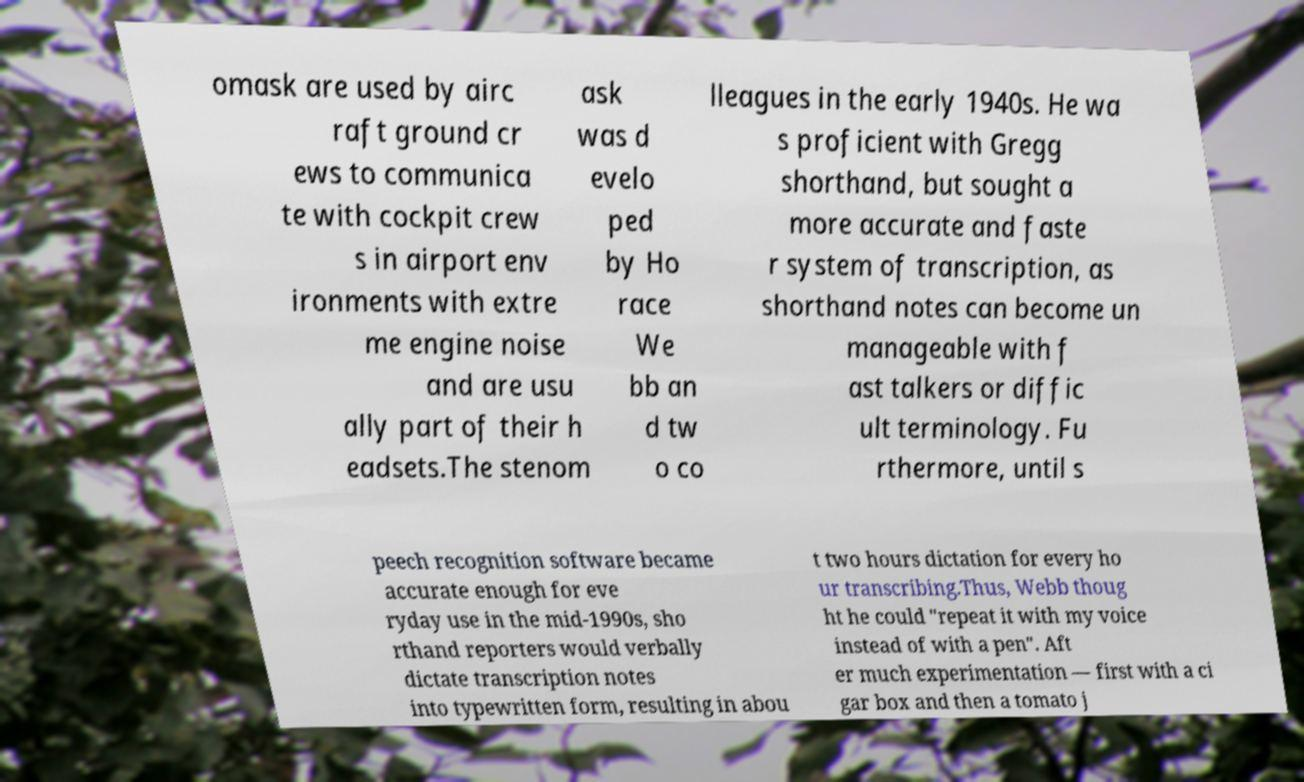What messages or text are displayed in this image? I need them in a readable, typed format. omask are used by airc raft ground cr ews to communica te with cockpit crew s in airport env ironments with extre me engine noise and are usu ally part of their h eadsets.The stenom ask was d evelo ped by Ho race We bb an d tw o co lleagues in the early 1940s. He wa s proficient with Gregg shorthand, but sought a more accurate and faste r system of transcription, as shorthand notes can become un manageable with f ast talkers or diffic ult terminology. Fu rthermore, until s peech recognition software became accurate enough for eve ryday use in the mid-1990s, sho rthand reporters would verbally dictate transcription notes into typewritten form, resulting in abou t two hours dictation for every ho ur transcribing.Thus, Webb thoug ht he could "repeat it with my voice instead of with a pen". Aft er much experimentation — first with a ci gar box and then a tomato j 